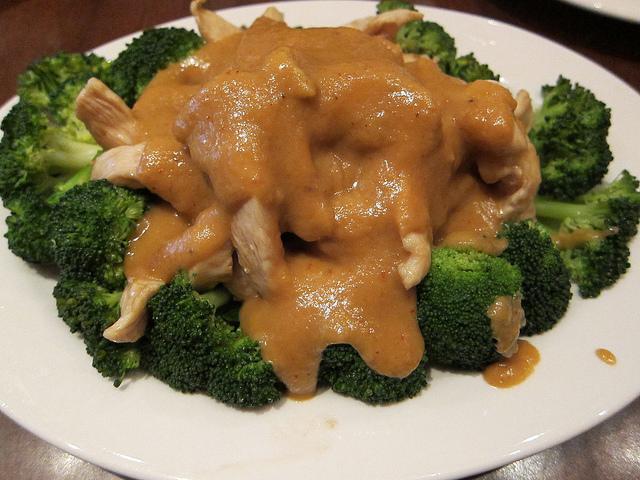How many broccolis can be seen?
Give a very brief answer. 3. How many men are present?
Give a very brief answer. 0. 